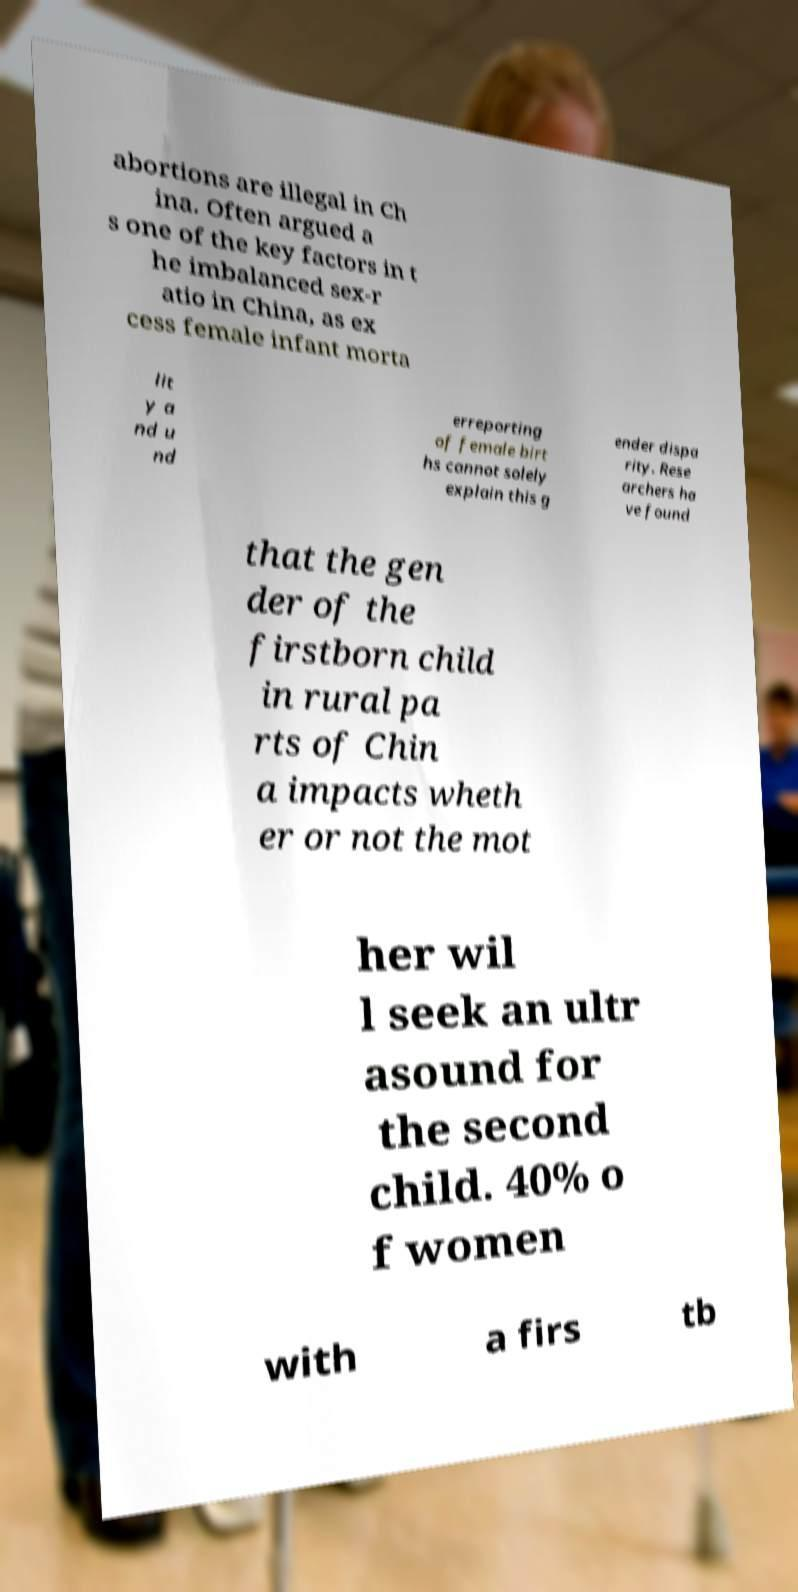For documentation purposes, I need the text within this image transcribed. Could you provide that? abortions are illegal in Ch ina. Often argued a s one of the key factors in t he imbalanced sex-r atio in China, as ex cess female infant morta lit y a nd u nd erreporting of female birt hs cannot solely explain this g ender dispa rity. Rese archers ha ve found that the gen der of the firstborn child in rural pa rts of Chin a impacts wheth er or not the mot her wil l seek an ultr asound for the second child. 40% o f women with a firs tb 